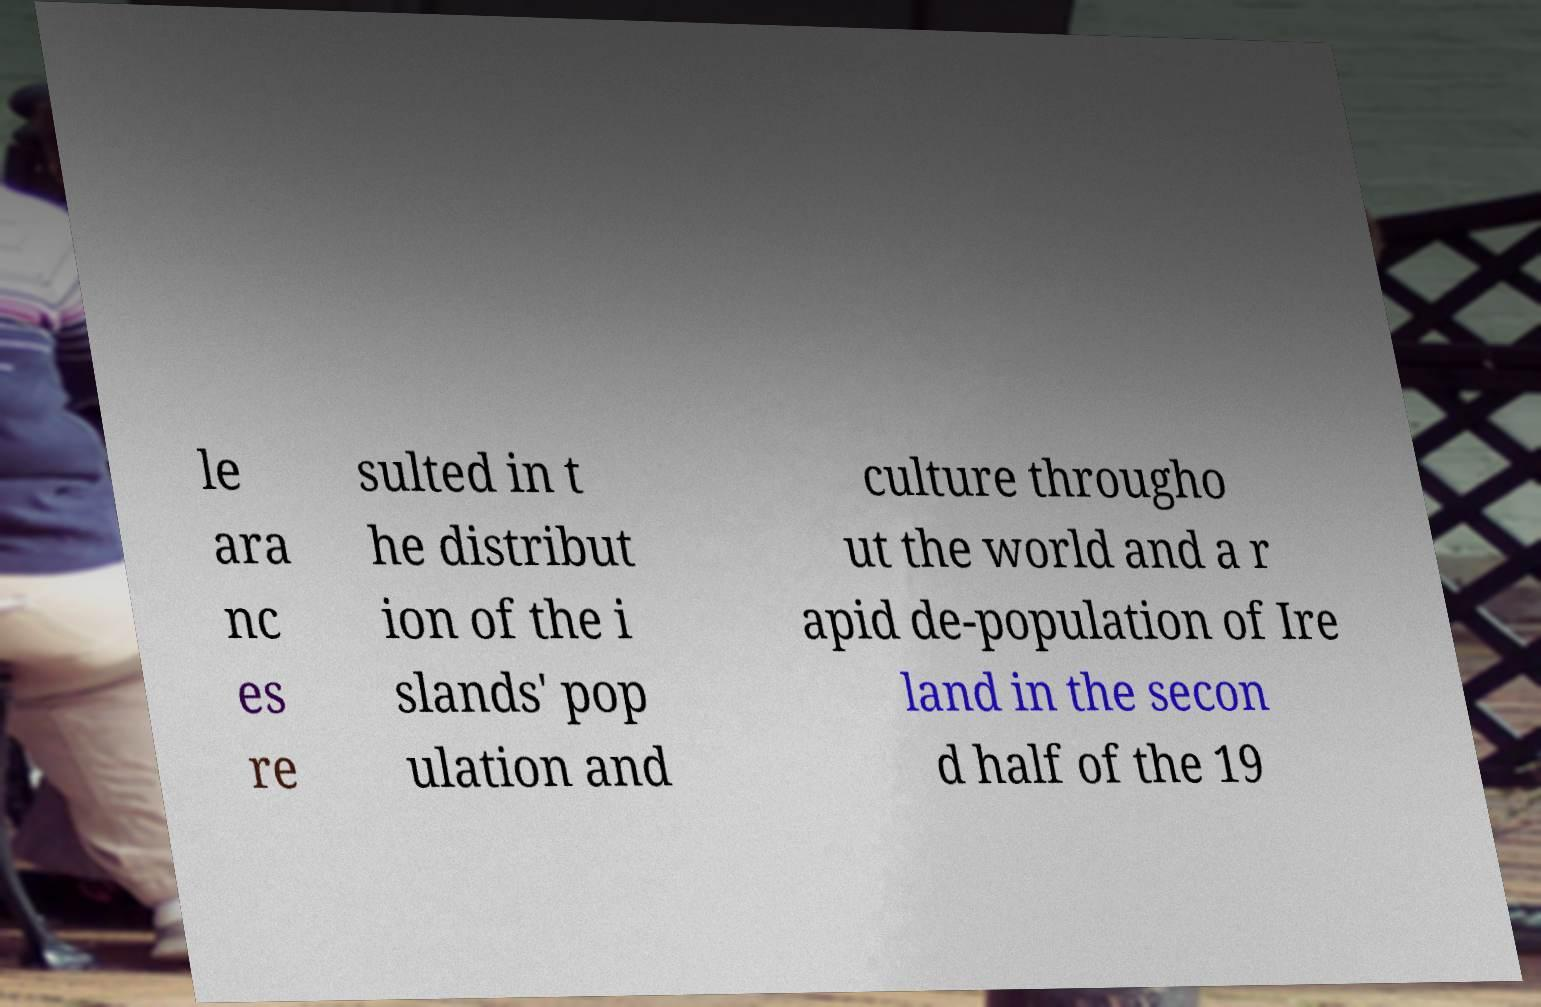Can you read and provide the text displayed in the image?This photo seems to have some interesting text. Can you extract and type it out for me? le ara nc es re sulted in t he distribut ion of the i slands' pop ulation and culture througho ut the world and a r apid de-population of Ire land in the secon d half of the 19 